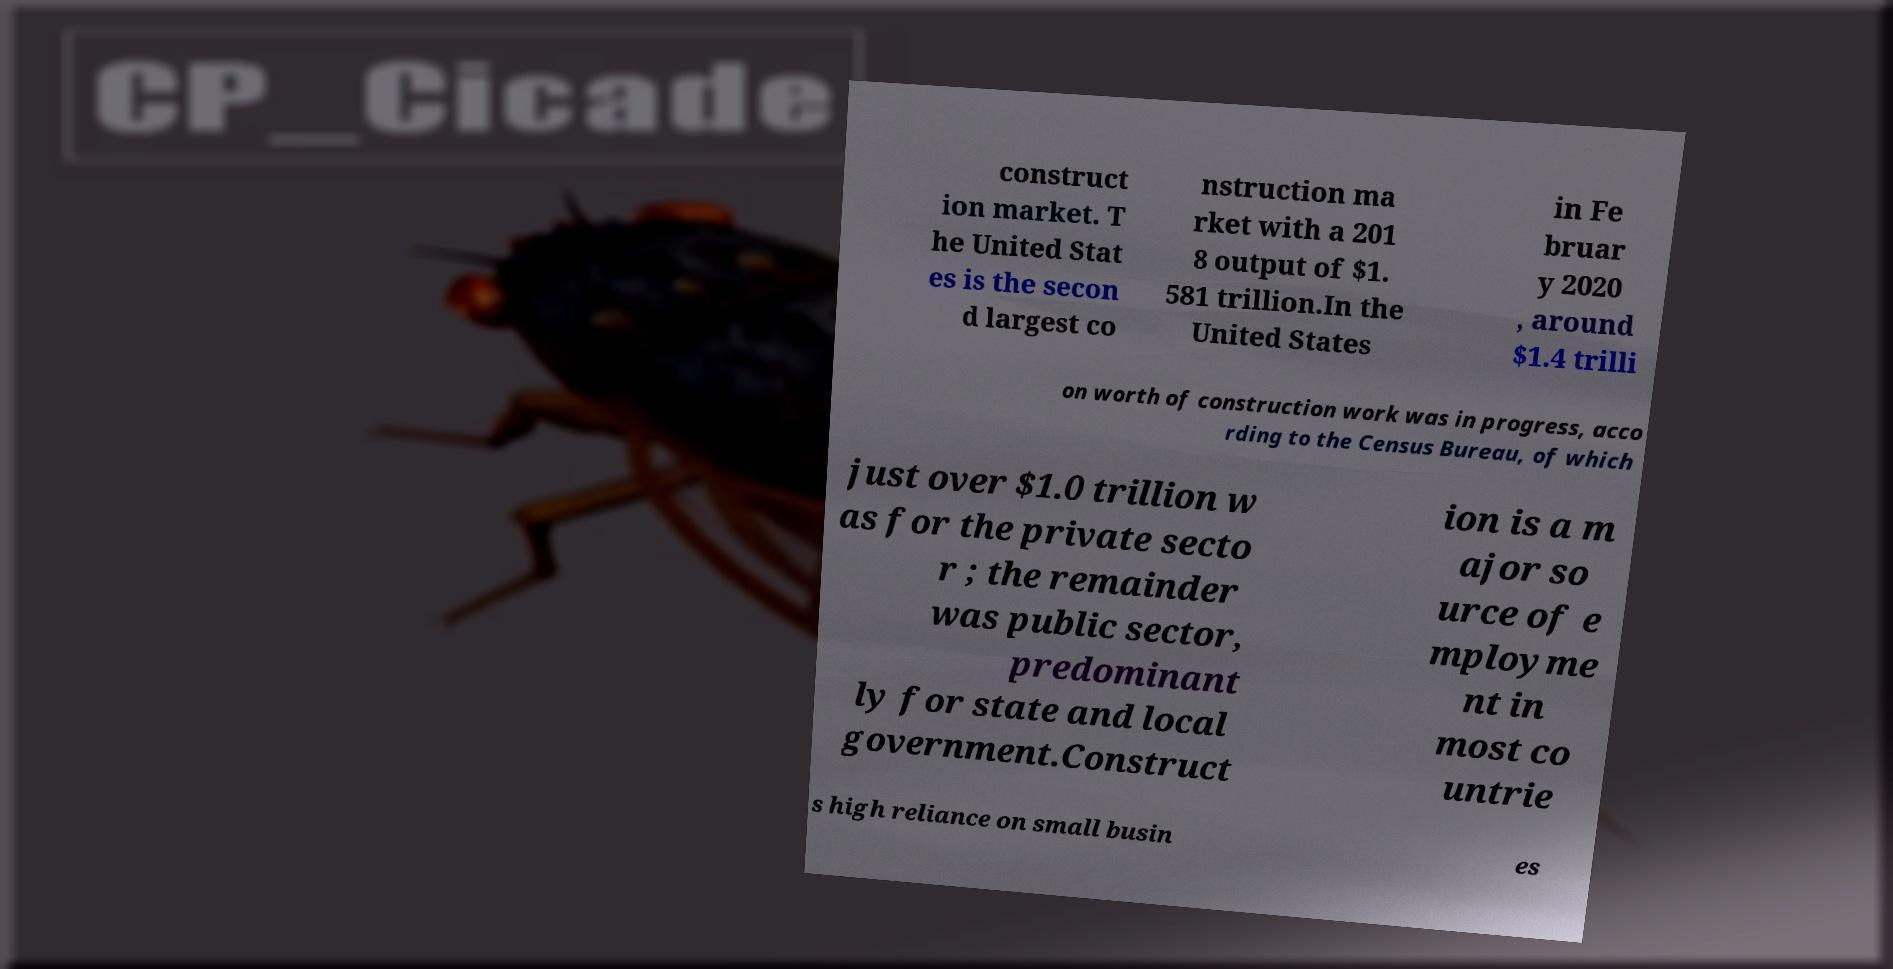What messages or text are displayed in this image? I need them in a readable, typed format. construct ion market. T he United Stat es is the secon d largest co nstruction ma rket with a 201 8 output of $1. 581 trillion.In the United States in Fe bruar y 2020 , around $1.4 trilli on worth of construction work was in progress, acco rding to the Census Bureau, of which just over $1.0 trillion w as for the private secto r ; the remainder was public sector, predominant ly for state and local government.Construct ion is a m ajor so urce of e mployme nt in most co untrie s high reliance on small busin es 